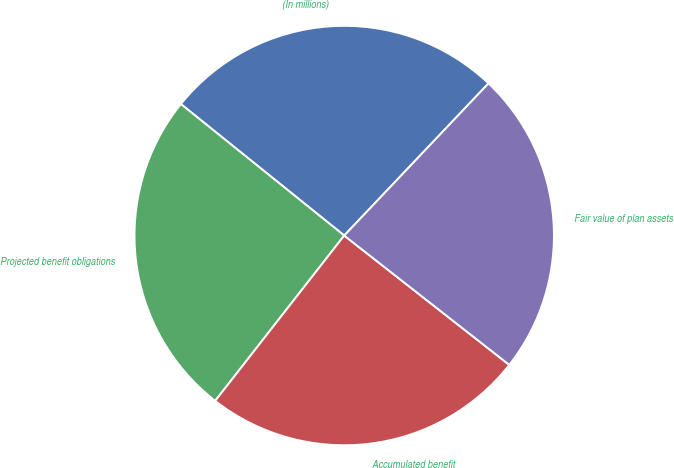Convert chart to OTSL. <chart><loc_0><loc_0><loc_500><loc_500><pie_chart><fcel>(In millions)<fcel>Projected benefit obligations<fcel>Accumulated benefit<fcel>Fair value of plan assets<nl><fcel>26.29%<fcel>25.24%<fcel>24.97%<fcel>23.5%<nl></chart> 